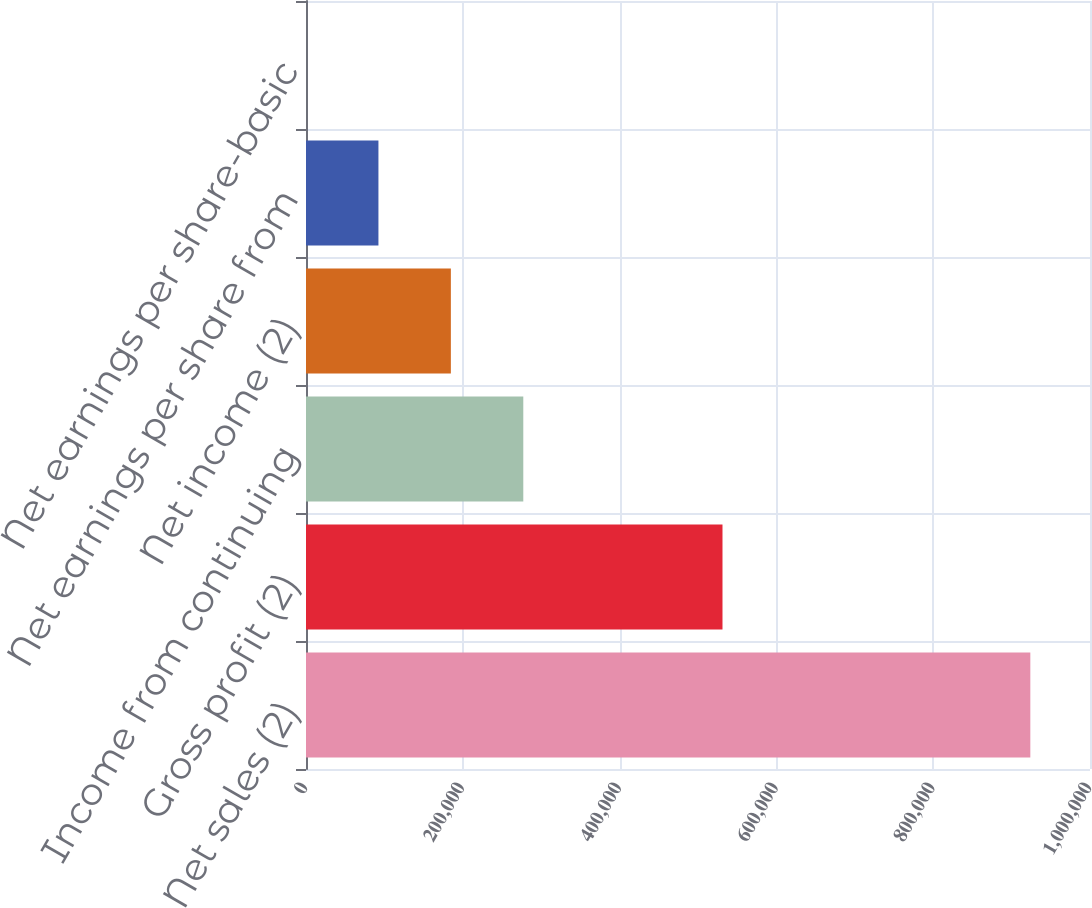<chart> <loc_0><loc_0><loc_500><loc_500><bar_chart><fcel>Net sales (2)<fcel>Gross profit (2)<fcel>Income from continuing<fcel>Net income (2)<fcel>Net earnings per share from<fcel>Net earnings per share-basic<nl><fcel>923885<fcel>531239<fcel>277167<fcel>184778<fcel>92390<fcel>1.65<nl></chart> 